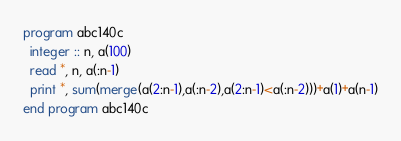<code> <loc_0><loc_0><loc_500><loc_500><_FORTRAN_>program abc140c
  integer :: n, a(100)
  read *, n, a(:n-1)
  print *, sum(merge(a(2:n-1),a(:n-2),a(2:n-1)<a(:n-2)))+a(1)+a(n-1)
end program abc140c
</code> 